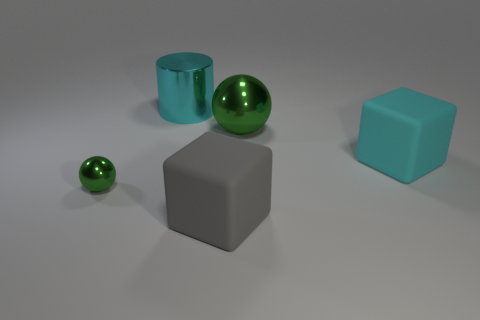Are there any other things that have the same shape as the small green metal thing?
Make the answer very short. Yes. What is the color of the other metallic object that is the same shape as the small thing?
Your answer should be compact. Green. What is the material of the large cyan object right of the cylinder?
Your response must be concise. Rubber. The big cylinder has what color?
Your answer should be very brief. Cyan. Does the green shiny thing that is right of the gray rubber cube have the same size as the cyan matte block?
Give a very brief answer. Yes. The big object that is right of the big metal object in front of the large cyan metallic cylinder that is behind the large gray rubber cube is made of what material?
Ensure brevity in your answer.  Rubber. There is a block that is to the left of the big cyan rubber thing; is its color the same as the rubber cube that is to the right of the big metal sphere?
Provide a short and direct response. No. What material is the big block on the right side of the green shiny ball that is behind the small sphere?
Your response must be concise. Rubber. There is a ball that is the same size as the gray block; what is its color?
Your answer should be compact. Green. Do the large cyan rubber thing and the thing that is on the left side of the large metal cylinder have the same shape?
Your answer should be very brief. No. 